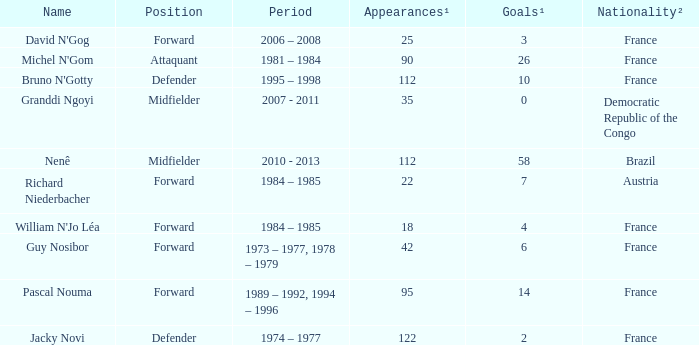List the player that scored 4 times. William N'Jo Léa. 